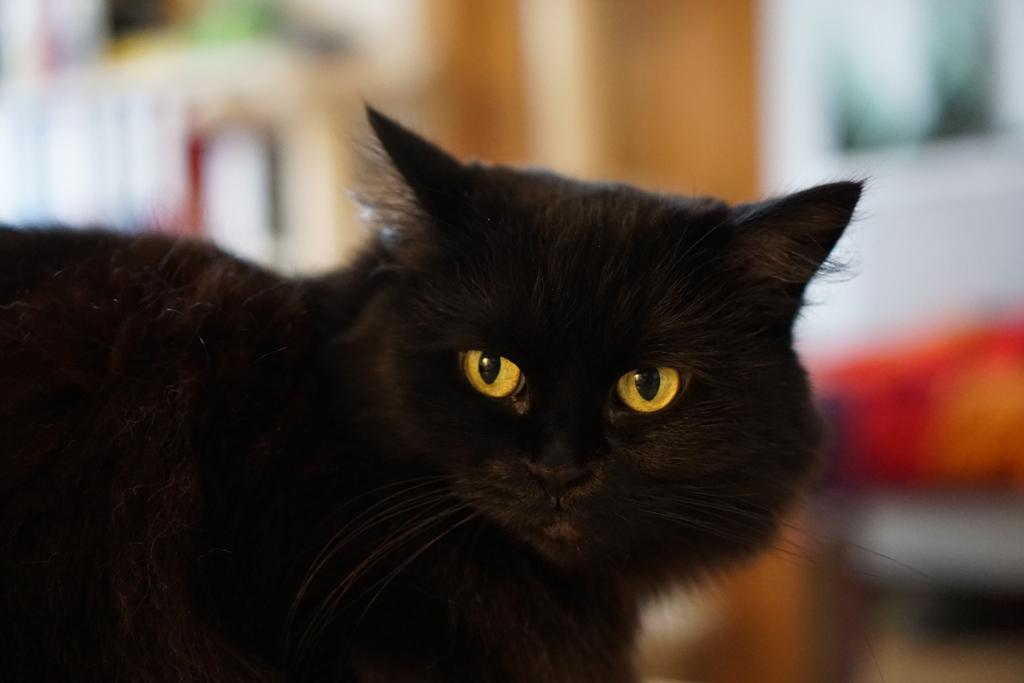What type of animal is in the image? There is a black color cat in the image. Can you describe the background of the image? The background of the image is blurry. What type of silver man can be seen walking in the winter scene in the image? There is no man, silver, or winter scene present in the image; it features a black color cat with a blurry background. 